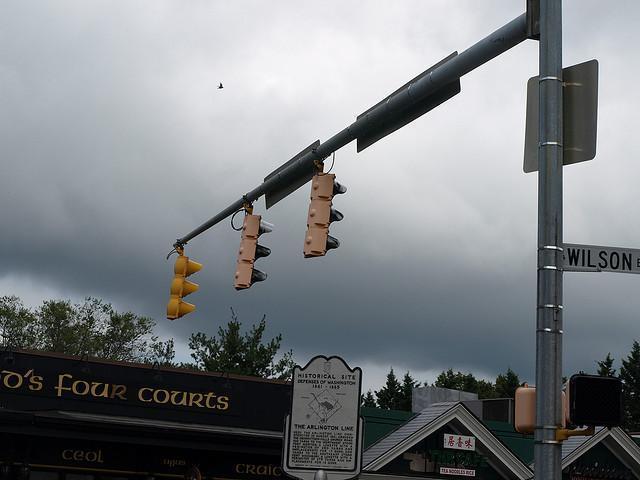How many traffic lights are there?
Give a very brief answer. 2. How many people have ties on?
Give a very brief answer. 0. 